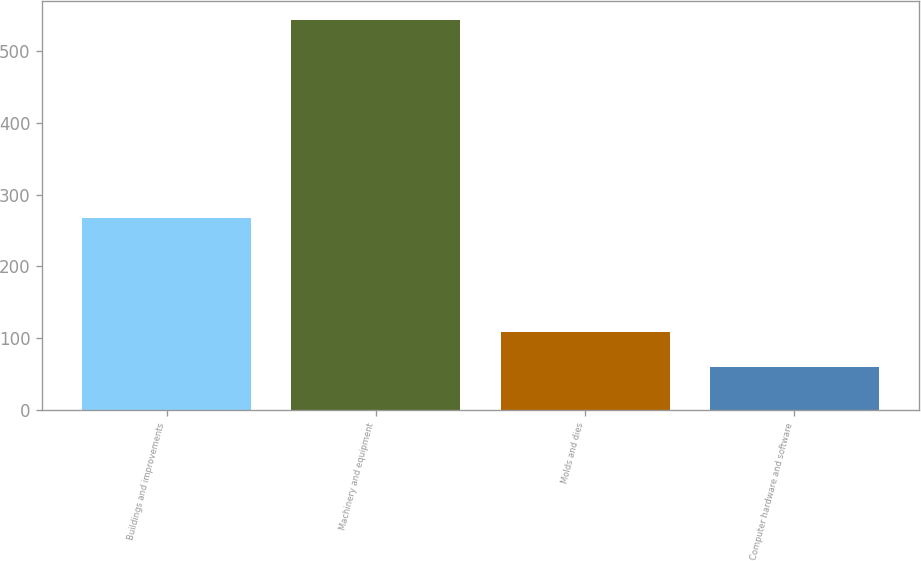<chart> <loc_0><loc_0><loc_500><loc_500><bar_chart><fcel>Buildings and improvements<fcel>Machinery and equipment<fcel>Molds and dies<fcel>Computer hardware and software<nl><fcel>267.1<fcel>543.9<fcel>108.3<fcel>59.9<nl></chart> 